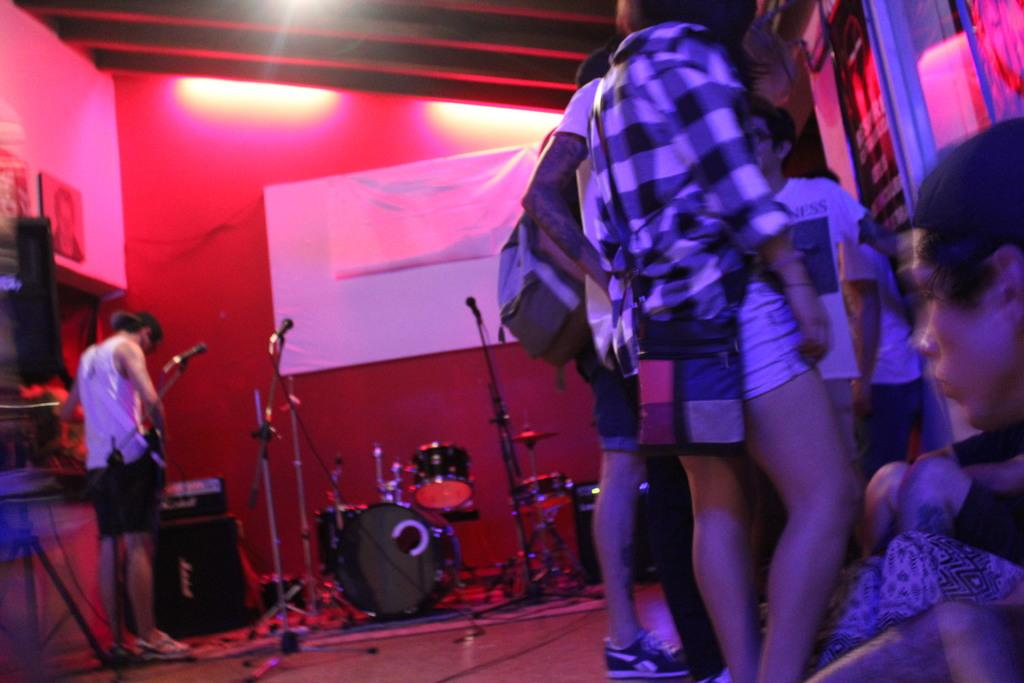What can be seen on the right side of the image? There are people on the right side of the image. What else is present in the image besides the people? There are likes and musical instruments in the image. What is visible at the top of the image? There are lights visible at the top of the image. What type of brass can be seen in the image? There is no brass present in the image. Can you tell me where the zoo is located in the image? There is no zoo present in the image. 